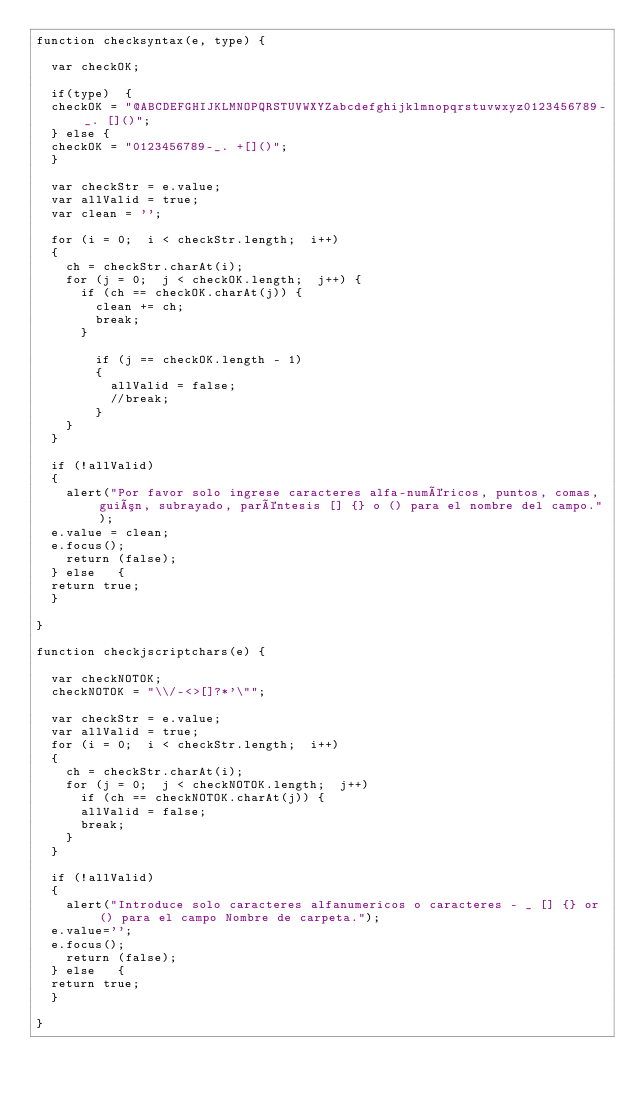<code> <loc_0><loc_0><loc_500><loc_500><_JavaScript_>function checksyntax(e, type)	{

  var checkOK;

  if(type)	{
  checkOK = "@ABCDEFGHIJKLMNOPQRSTUVWXYZabcdefghijklmnopqrstuvwxyz0123456789-_. []()";
  } else {
  checkOK = "0123456789-_. +[]()";
  }

  var checkStr = e.value;
  var allValid = true;
  var clean = '';

  for (i = 0;  i < checkStr.length;  i++)
  {
    ch = checkStr.charAt(i);
    for (j = 0;  j < checkOK.length;  j++) {
      if (ch == checkOK.charAt(j)) {
        clean += ch;
        break;
      }

        if (j == checkOK.length - 1)
        {
          allValid = false;
          //break;
        }
    }
  }

  if (!allValid)
  {
    alert("Por favor solo ingrese caracteres alfa-numéricos, puntos, comas, guión, subrayado, paréntesis [] {} o () para el nombre del campo.");
	e.value = clean;
	e.focus();
    return (false);
  } else	 {
	return true;
  }

}

function checkjscriptchars(e)	{

  var checkNOTOK;
  checkNOTOK = "\\/-<>[]?*'\"";

  var checkStr = e.value;
  var allValid = true;
  for (i = 0;  i < checkStr.length;  i++)
  {
    ch = checkStr.charAt(i);
    for (j = 0;  j < checkNOTOK.length;  j++)
      if (ch == checkNOTOK.charAt(j)) {
      allValid = false;
      break;
    }
  }

  if (!allValid)
  {
    alert("Introduce solo caracteres alfanumericos o caracteres - _ [] {} or () para el campo Nombre de carpeta.");
	e.value='';
	e.focus();
    return (false);
  } else	 {
	return true;
  }

}
</code> 